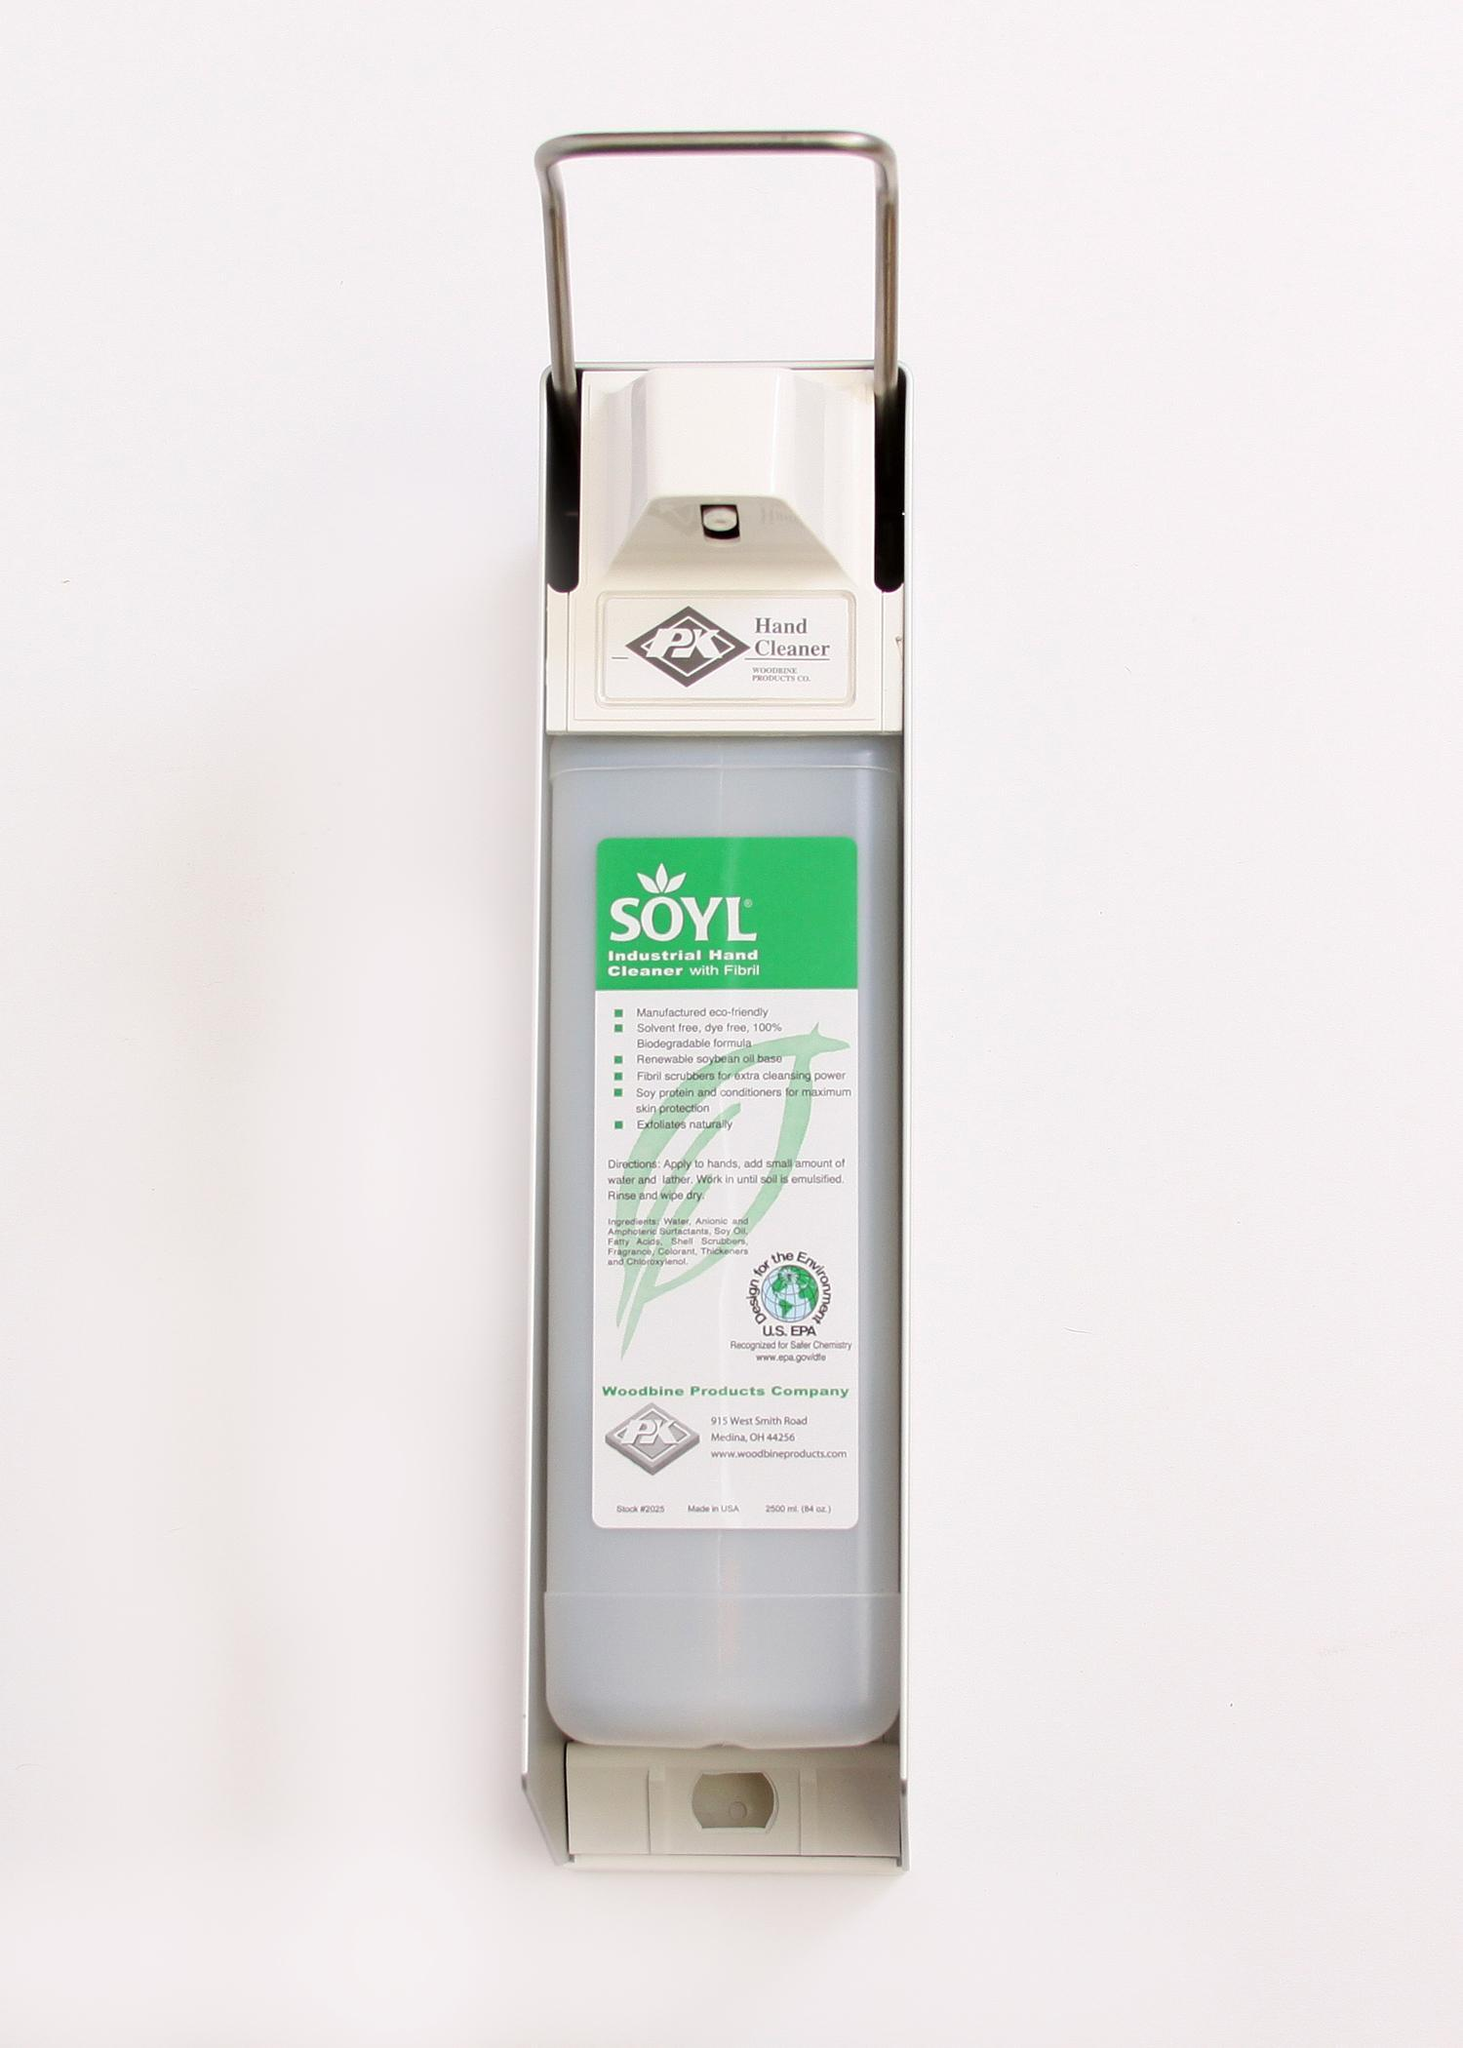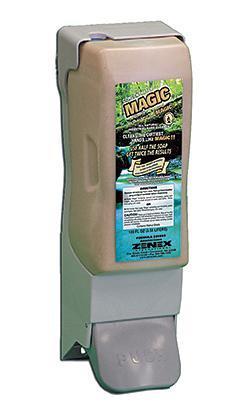The first image is the image on the left, the second image is the image on the right. Evaluate the accuracy of this statement regarding the images: "The left and right image contains the same number of full wall hanging soap dispensers.". Is it true? Answer yes or no. Yes. The first image is the image on the left, the second image is the image on the right. Assess this claim about the two images: "One soap container is brown.". Correct or not? Answer yes or no. Yes. 